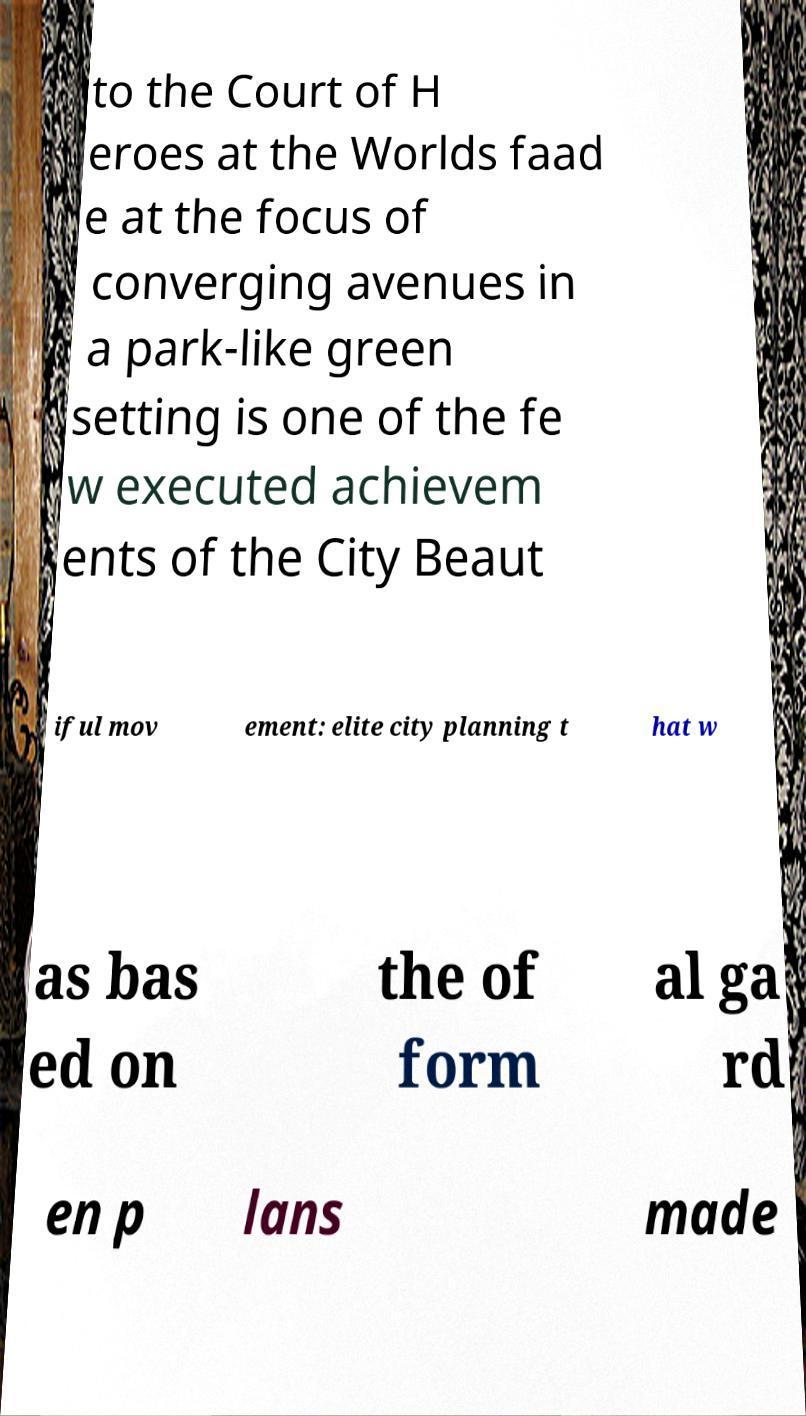There's text embedded in this image that I need extracted. Can you transcribe it verbatim? to the Court of H eroes at the Worlds faad e at the focus of converging avenues in a park-like green setting is one of the fe w executed achievem ents of the City Beaut iful mov ement: elite city planning t hat w as bas ed on the of form al ga rd en p lans made 